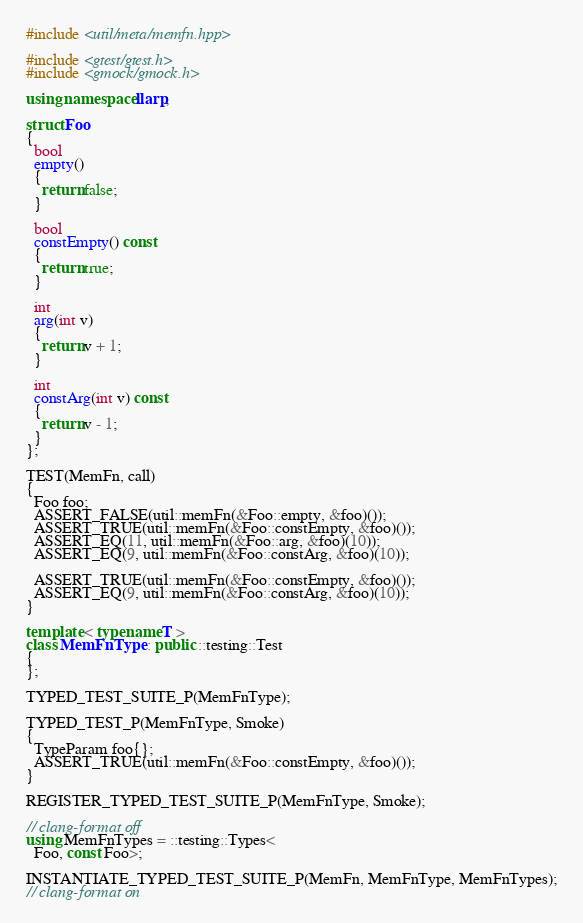<code> <loc_0><loc_0><loc_500><loc_500><_C++_>#include <util/meta/memfn.hpp>

#include <gtest/gtest.h>
#include <gmock/gmock.h>

using namespace llarp;

struct Foo
{
  bool
  empty()
  {
    return false;
  }

  bool
  constEmpty() const
  {
    return true;
  }

  int
  arg(int v)
  {
    return v + 1;
  }

  int
  constArg(int v) const
  {
    return v - 1;
  }
};

TEST(MemFn, call)
{
  Foo foo;
  ASSERT_FALSE(util::memFn(&Foo::empty, &foo)());
  ASSERT_TRUE(util::memFn(&Foo::constEmpty, &foo)());
  ASSERT_EQ(11, util::memFn(&Foo::arg, &foo)(10));
  ASSERT_EQ(9, util::memFn(&Foo::constArg, &foo)(10));

  ASSERT_TRUE(util::memFn(&Foo::constEmpty, &foo)());
  ASSERT_EQ(9, util::memFn(&Foo::constArg, &foo)(10));
}

template < typename T >
class MemFnType : public ::testing::Test
{
};

TYPED_TEST_SUITE_P(MemFnType);

TYPED_TEST_P(MemFnType, Smoke)
{
  TypeParam foo{};
  ASSERT_TRUE(util::memFn(&Foo::constEmpty, &foo)());
}

REGISTER_TYPED_TEST_SUITE_P(MemFnType, Smoke);

// clang-format off
using MemFnTypes = ::testing::Types<
  Foo, const Foo>;

INSTANTIATE_TYPED_TEST_SUITE_P(MemFn, MemFnType, MemFnTypes);
// clang-format on
</code> 